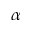<formula> <loc_0><loc_0><loc_500><loc_500>\alpha</formula> 